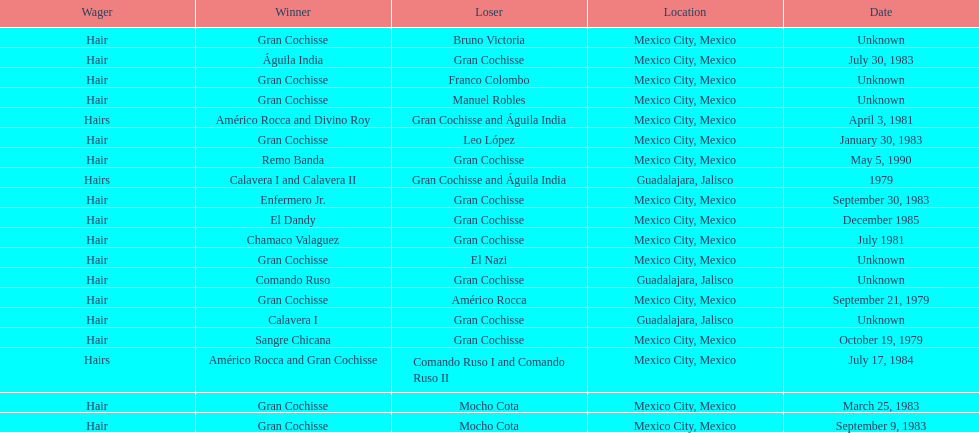What was the number of losses gran cochisse had against el dandy? 1. 